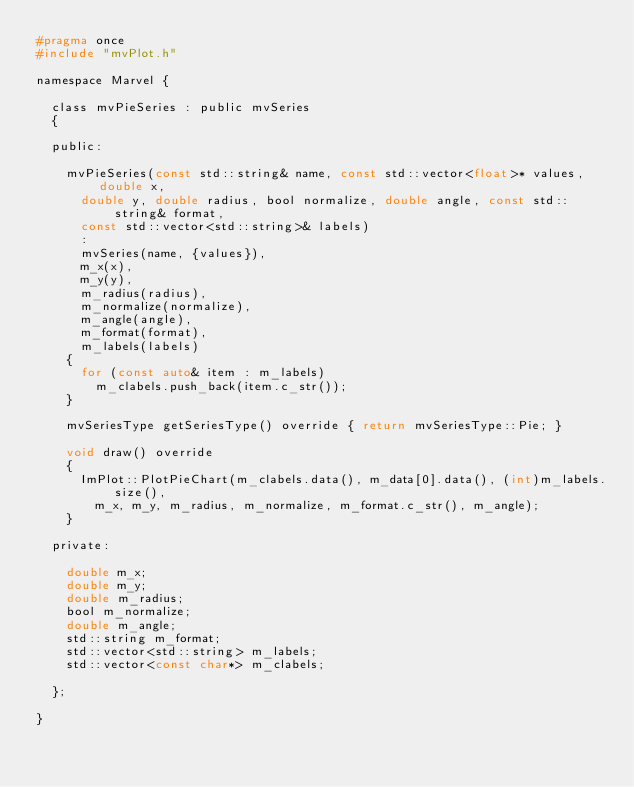<code> <loc_0><loc_0><loc_500><loc_500><_C_>#pragma once
#include "mvPlot.h"

namespace Marvel {

	class mvPieSeries : public mvSeries
	{

	public:

		mvPieSeries(const std::string& name, const std::vector<float>* values, double x,
			double y, double radius, bool normalize, double angle, const std::string& format,
			const std::vector<std::string>& labels)
			: 
			mvSeries(name, {values}),
			m_x(x), 
			m_y(y),
			m_radius(radius), 
			m_normalize(normalize),
			m_angle(angle), 
			m_format(format), 
			m_labels(labels)
		{
			for (const auto& item : m_labels)
				m_clabels.push_back(item.c_str());
		}

		mvSeriesType getSeriesType() override { return mvSeriesType::Pie; }

		void draw() override
		{
			ImPlot::PlotPieChart(m_clabels.data(), m_data[0].data(), (int)m_labels.size(),
				m_x, m_y, m_radius, m_normalize, m_format.c_str(), m_angle);
		}

	private:

		double m_x;
		double m_y;
		double m_radius;
		bool m_normalize;
		double m_angle;
		std::string m_format;
		std::vector<std::string> m_labels;
		std::vector<const char*> m_clabels;

	};

}</code> 